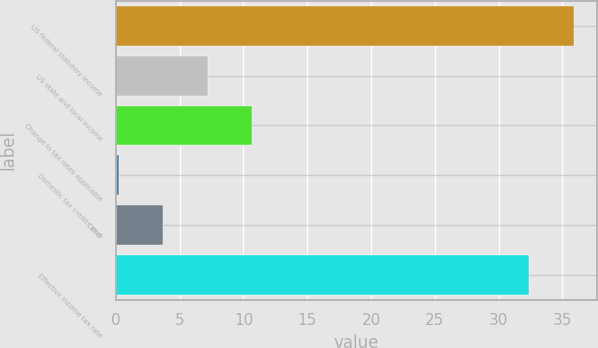Convert chart. <chart><loc_0><loc_0><loc_500><loc_500><bar_chart><fcel>US federal statutory income<fcel>US state and local income<fcel>Change in tax rates applicable<fcel>Domestic tax credits and<fcel>Other<fcel>Effective income tax rate<nl><fcel>35.88<fcel>7.2<fcel>10.67<fcel>0.26<fcel>3.73<fcel>32.41<nl></chart> 